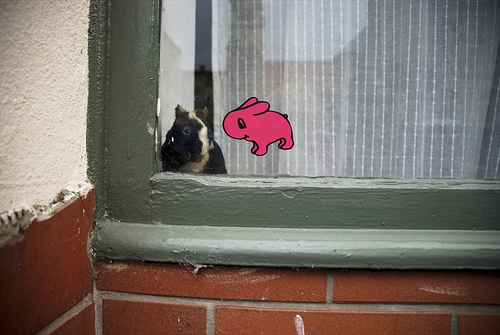<image>
Can you confirm if the sticker is on the window? Yes. Looking at the image, I can see the sticker is positioned on top of the window, with the window providing support. Is there a real rodent behind the cartoon rodent? Yes. From this viewpoint, the real rodent is positioned behind the cartoon rodent, with the cartoon rodent partially or fully occluding the real rodent. Is the window decal to the right of the pet? Yes. From this viewpoint, the window decal is positioned to the right side relative to the pet. Is there a animal in the house? Yes. The animal is contained within or inside the house, showing a containment relationship. 